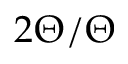<formula> <loc_0><loc_0><loc_500><loc_500>2 \Theta / \Theta</formula> 